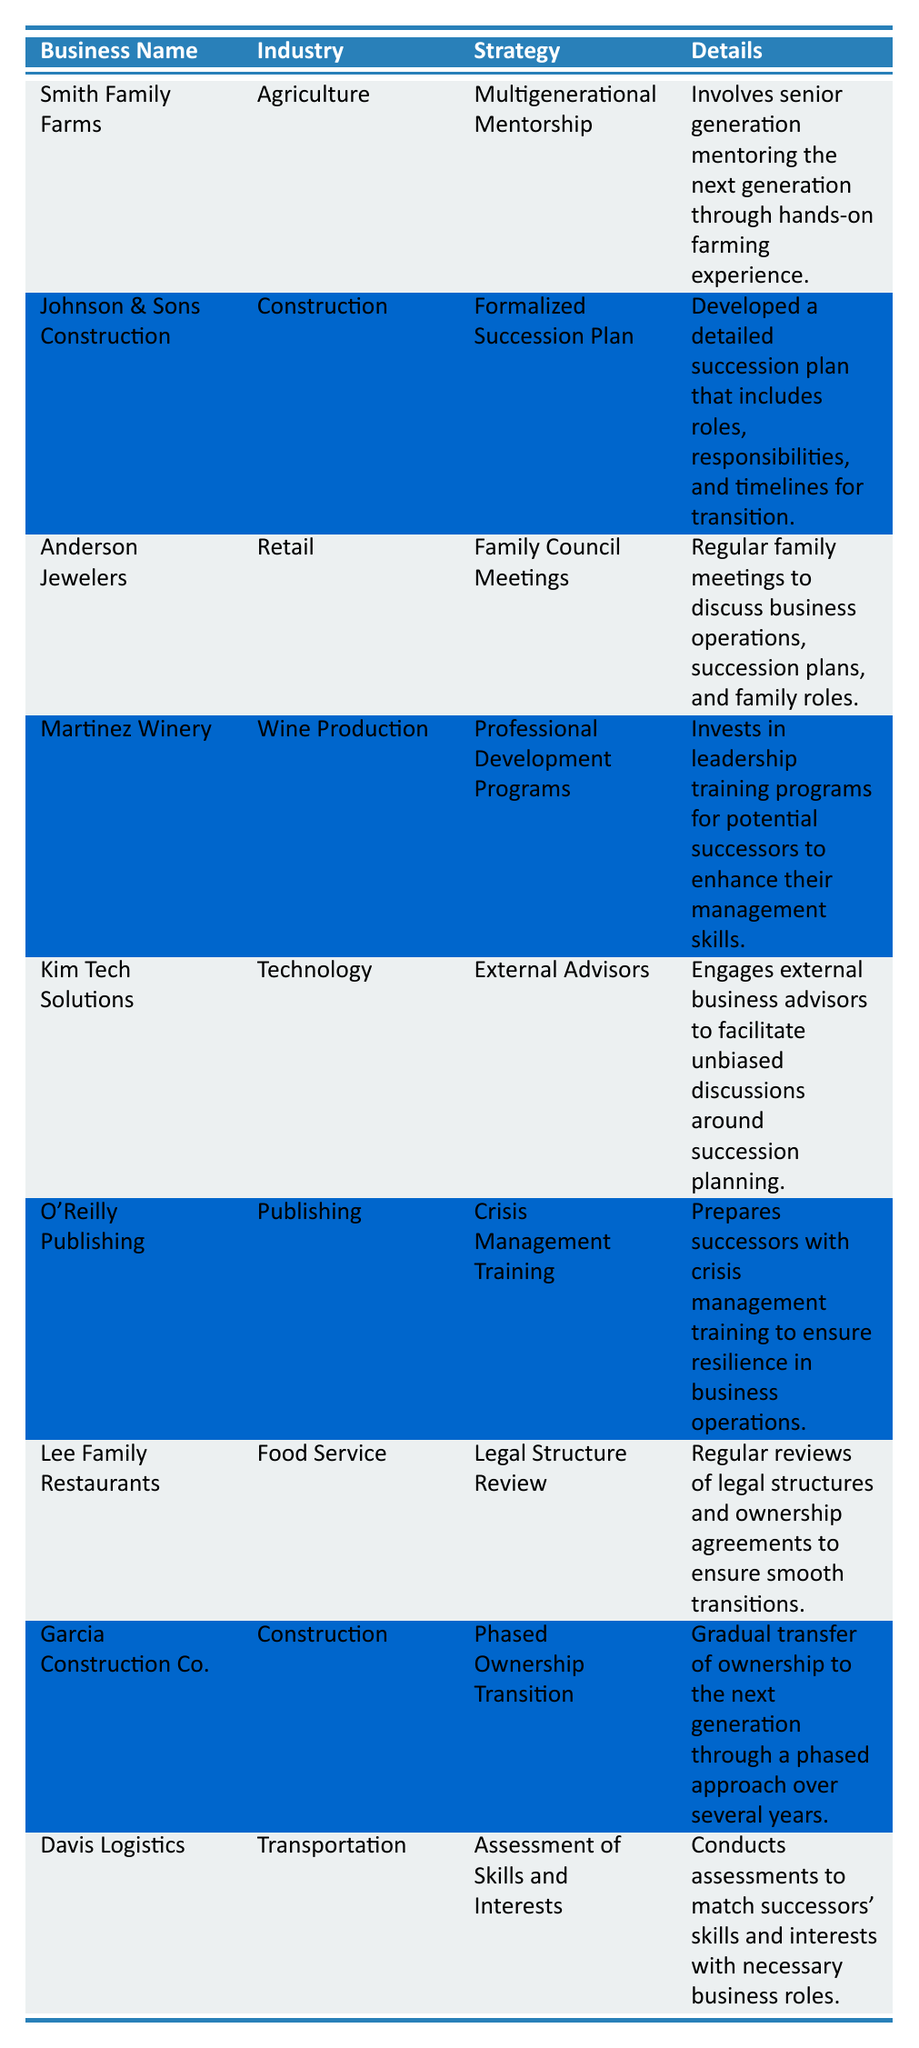What is the strategy employed by Smith Family Farms? According to the table, Smith Family Farms employs the strategy of "Multigenerational Mentorship."
Answer: Multigenerational Mentorship Which industry does Kim Tech Solutions operate in? The table states that Kim Tech Solutions operates in the "Technology" industry.
Answer: Technology How many businesses employ "Construction" as their industry? There are two businesses listed under the "Construction" industry: Johnson & Sons Construction and Garcia Construction Co.
Answer: 2 What details are provided for the strategy called "Family Council Meetings"? The table describes "Family Council Meetings" as involving regular family meetings to discuss business operations, succession plans, and family roles.
Answer: Regular family meetings to discuss operations, plans, and roles Is there a business that uses external advisors for succession planning? Yes, Kim Tech Solutions engages external business advisors to facilitate discussions around succession planning.
Answer: Yes What is the common strategy between Garcia Construction Co. and Johnson & Sons Construction? Both businesses operate in the construction industry but employ different strategies; Garcia Construction Co. has a "Phased Ownership Transition," while Johnson & Sons Construction has a "Formalized Succession Plan." Therefore, they do not share a common strategy.
Answer: No How many strategies involve training or development programs for successors? The table lists two strategies that involve training or development programs: "Professional Development Programs" (Martinez Winery) and "Crisis Management Training" (O'Reilly Publishing).
Answer: 2 Which business operates in the Food Service industry, and what is their strategy? The business in the Food Service industry is Lee Family Restaurants, and their strategy is "Legal Structure Review."
Answer: Lee Family Restaurants; Legal Structure Review What strategy includes a gradual transfer of ownership? The strategy called "Phased Ownership Transition" includes a gradual transfer of ownership to the next generation over several years, as described for Garcia Construction Co.
Answer: Phased Ownership Transition Which business strategy focuses on assessing skills and interests? The strategy "Assessment of Skills and Interests" is focused on conducting assessments to match successors' skills and interests with necessary business roles, provided by Davis Logistics.
Answer: Assessment of Skills and Interests What type of training is included in O'Reilly Publishing's succession strategy? O'Reilly Publishing's succession strategy includes "Crisis Management Training" to prepare successors for resilience in business operations.
Answer: Crisis Management Training 